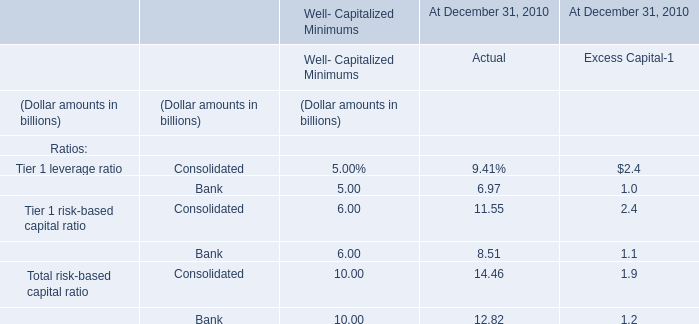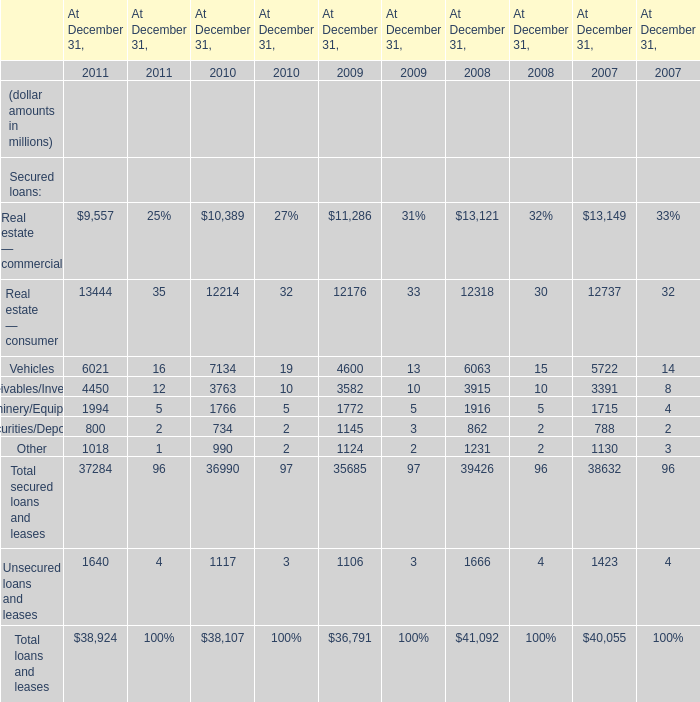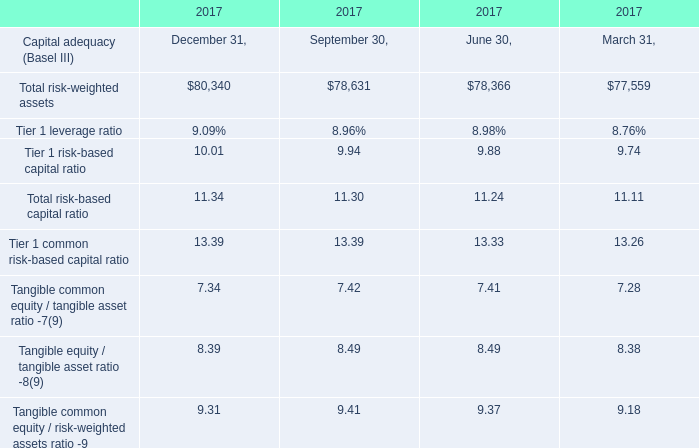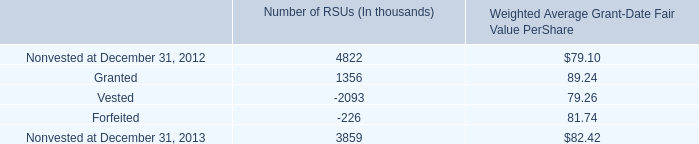In the year with lowest amount of Securities/Deposits, what's the increasing rate of Machinery/Equipment? 
Computations: ((1766 - 1772) / 1772)
Answer: -0.00339. 